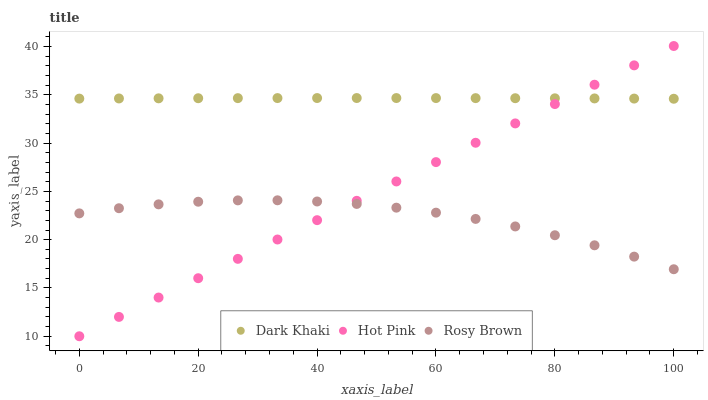Does Rosy Brown have the minimum area under the curve?
Answer yes or no. Yes. Does Dark Khaki have the maximum area under the curve?
Answer yes or no. Yes. Does Hot Pink have the minimum area under the curve?
Answer yes or no. No. Does Hot Pink have the maximum area under the curve?
Answer yes or no. No. Is Hot Pink the smoothest?
Answer yes or no. Yes. Is Rosy Brown the roughest?
Answer yes or no. Yes. Is Rosy Brown the smoothest?
Answer yes or no. No. Is Hot Pink the roughest?
Answer yes or no. No. Does Hot Pink have the lowest value?
Answer yes or no. Yes. Does Rosy Brown have the lowest value?
Answer yes or no. No. Does Hot Pink have the highest value?
Answer yes or no. Yes. Does Rosy Brown have the highest value?
Answer yes or no. No. Is Rosy Brown less than Dark Khaki?
Answer yes or no. Yes. Is Dark Khaki greater than Rosy Brown?
Answer yes or no. Yes. Does Hot Pink intersect Dark Khaki?
Answer yes or no. Yes. Is Hot Pink less than Dark Khaki?
Answer yes or no. No. Is Hot Pink greater than Dark Khaki?
Answer yes or no. No. Does Rosy Brown intersect Dark Khaki?
Answer yes or no. No. 